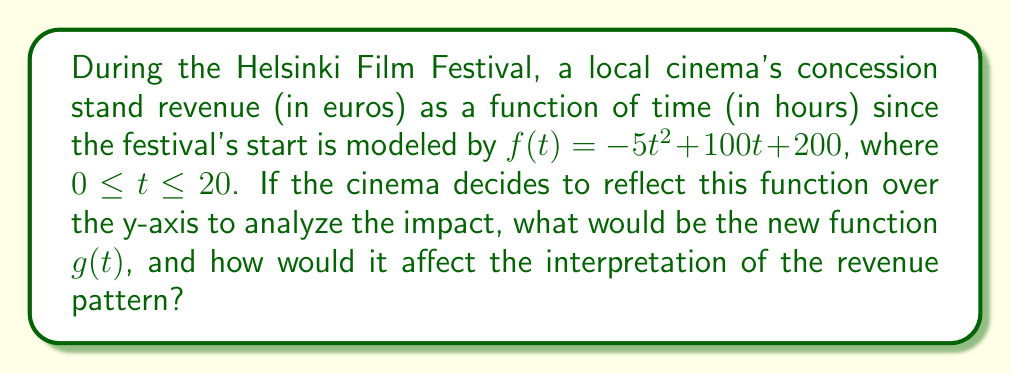Give your solution to this math problem. To reflect the function $f(t) = -5t^2 + 100t + 200$ over the y-axis, we need to replace every $t$ with $-t$. This process gives us:

1) Start with $f(t) = -5t^2 + 100t + 200$
2) Replace $t$ with $-t$:
   $g(t) = -5(-t)^2 + 100(-t) + 200$

3) Simplify:
   $g(t) = -5t^2 - 100t + 200$

The new function $g(t)$ represents the reflection of $f(t)$ over the y-axis.

Interpretation of the change:
- The coefficient of $t^2$ remains negative, so the parabola still opens downward.
- The linear term changes from $+100t$ to $-100t$, which shifts the axis of symmetry to the left.
- The y-intercept (200) remains the same, as it represents the point where the graph crosses the y-axis.

In the context of the cinema's revenue:
- Originally, revenue increased, peaked, then decreased as the festival progressed.
- With the reflected function, it appears as if revenue starts high, decreases, then slightly increases towards the end.
- This reflection essentially reverses the time progression, which doesn't make practical sense for real-world revenue but could be used for comparative analysis or hypothetical scenarios.
Answer: $g(t) = -5t^2 - 100t + 200$ 